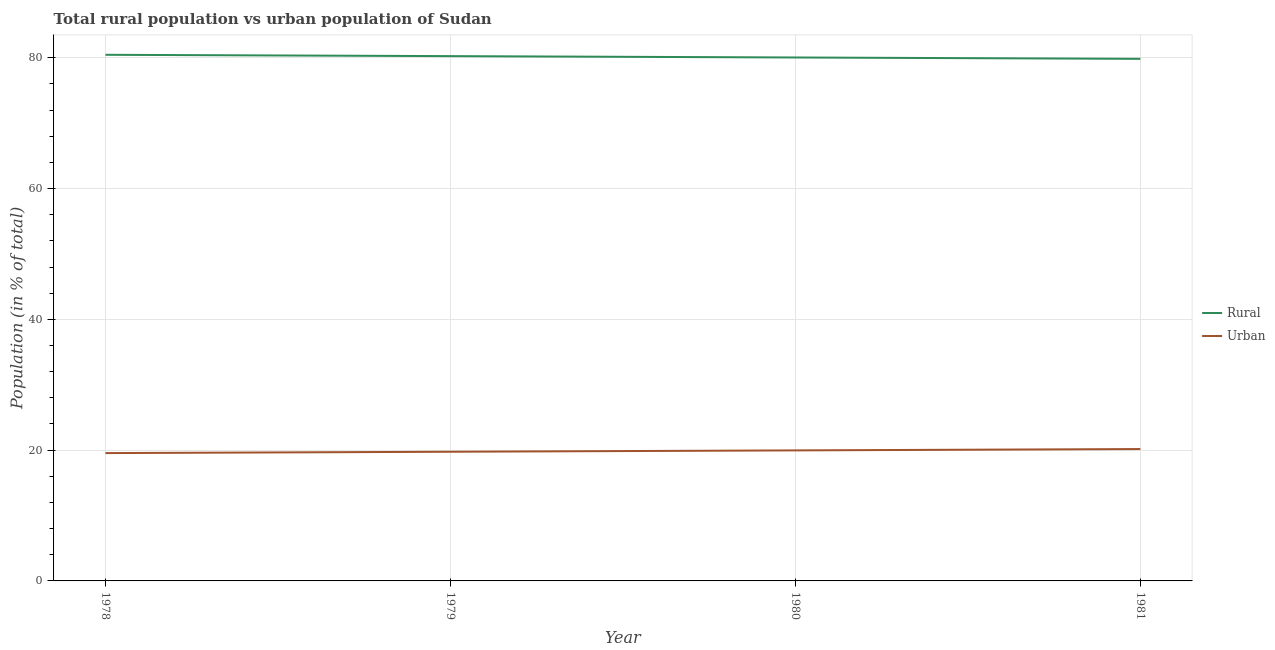Does the line corresponding to rural population intersect with the line corresponding to urban population?
Your response must be concise. No. What is the rural population in 1981?
Ensure brevity in your answer.  79.83. Across all years, what is the maximum urban population?
Offer a terse response. 20.17. Across all years, what is the minimum urban population?
Make the answer very short. 19.55. In which year was the urban population minimum?
Ensure brevity in your answer.  1978. What is the total urban population in the graph?
Ensure brevity in your answer.  79.42. What is the difference between the urban population in 1980 and that in 1981?
Offer a terse response. -0.21. What is the difference between the rural population in 1980 and the urban population in 1978?
Your response must be concise. 60.49. What is the average urban population per year?
Make the answer very short. 19.86. In the year 1981, what is the difference between the rural population and urban population?
Give a very brief answer. 59.67. In how many years, is the urban population greater than 68 %?
Keep it short and to the point. 0. What is the ratio of the rural population in 1978 to that in 1979?
Give a very brief answer. 1. Is the difference between the rural population in 1979 and 1981 greater than the difference between the urban population in 1979 and 1981?
Offer a very short reply. Yes. What is the difference between the highest and the second highest urban population?
Offer a very short reply. 0.21. What is the difference between the highest and the lowest urban population?
Your response must be concise. 0.62. In how many years, is the urban population greater than the average urban population taken over all years?
Your answer should be very brief. 2. Is the sum of the urban population in 1980 and 1981 greater than the maximum rural population across all years?
Offer a very short reply. No. Does the urban population monotonically increase over the years?
Keep it short and to the point. Yes. Is the urban population strictly greater than the rural population over the years?
Provide a succinct answer. No. Is the urban population strictly less than the rural population over the years?
Your response must be concise. Yes. How many lines are there?
Your answer should be compact. 2. How many years are there in the graph?
Your answer should be very brief. 4. What is the difference between two consecutive major ticks on the Y-axis?
Your answer should be very brief. 20. Does the graph contain grids?
Make the answer very short. Yes. How many legend labels are there?
Make the answer very short. 2. How are the legend labels stacked?
Provide a succinct answer. Vertical. What is the title of the graph?
Ensure brevity in your answer.  Total rural population vs urban population of Sudan. What is the label or title of the Y-axis?
Your response must be concise. Population (in % of total). What is the Population (in % of total) of Rural in 1978?
Your answer should be compact. 80.45. What is the Population (in % of total) of Urban in 1978?
Provide a succinct answer. 19.55. What is the Population (in % of total) in Rural in 1979?
Offer a terse response. 80.25. What is the Population (in % of total) of Urban in 1979?
Ensure brevity in your answer.  19.75. What is the Population (in % of total) in Rural in 1980?
Make the answer very short. 80.04. What is the Population (in % of total) of Urban in 1980?
Provide a short and direct response. 19.96. What is the Population (in % of total) of Rural in 1981?
Your response must be concise. 79.83. What is the Population (in % of total) in Urban in 1981?
Keep it short and to the point. 20.17. Across all years, what is the maximum Population (in % of total) of Rural?
Your answer should be very brief. 80.45. Across all years, what is the maximum Population (in % of total) in Urban?
Provide a succinct answer. 20.17. Across all years, what is the minimum Population (in % of total) of Rural?
Provide a short and direct response. 79.83. Across all years, what is the minimum Population (in % of total) in Urban?
Your answer should be compact. 19.55. What is the total Population (in % of total) in Rural in the graph?
Ensure brevity in your answer.  320.58. What is the total Population (in % of total) in Urban in the graph?
Your answer should be compact. 79.42. What is the difference between the Population (in % of total) of Rural in 1978 and that in 1979?
Ensure brevity in your answer.  0.2. What is the difference between the Population (in % of total) of Urban in 1978 and that in 1979?
Offer a very short reply. -0.2. What is the difference between the Population (in % of total) in Rural in 1978 and that in 1980?
Offer a terse response. 0.41. What is the difference between the Population (in % of total) of Urban in 1978 and that in 1980?
Make the answer very short. -0.41. What is the difference between the Population (in % of total) in Rural in 1978 and that in 1981?
Provide a short and direct response. 0.62. What is the difference between the Population (in % of total) of Urban in 1978 and that in 1981?
Provide a short and direct response. -0.62. What is the difference between the Population (in % of total) in Rural in 1979 and that in 1980?
Make the answer very short. 0.21. What is the difference between the Population (in % of total) of Urban in 1979 and that in 1980?
Provide a succinct answer. -0.21. What is the difference between the Population (in % of total) in Rural in 1979 and that in 1981?
Keep it short and to the point. 0.41. What is the difference between the Population (in % of total) of Urban in 1979 and that in 1981?
Make the answer very short. -0.41. What is the difference between the Population (in % of total) of Rural in 1980 and that in 1981?
Your response must be concise. 0.21. What is the difference between the Population (in % of total) in Urban in 1980 and that in 1981?
Offer a very short reply. -0.21. What is the difference between the Population (in % of total) of Rural in 1978 and the Population (in % of total) of Urban in 1979?
Your response must be concise. 60.7. What is the difference between the Population (in % of total) in Rural in 1978 and the Population (in % of total) in Urban in 1980?
Provide a succinct answer. 60.49. What is the difference between the Population (in % of total) of Rural in 1978 and the Population (in % of total) of Urban in 1981?
Your answer should be compact. 60.29. What is the difference between the Population (in % of total) in Rural in 1979 and the Population (in % of total) in Urban in 1980?
Ensure brevity in your answer.  60.29. What is the difference between the Population (in % of total) of Rural in 1979 and the Population (in % of total) of Urban in 1981?
Your answer should be very brief. 60.08. What is the difference between the Population (in % of total) in Rural in 1980 and the Population (in % of total) in Urban in 1981?
Your answer should be compact. 59.88. What is the average Population (in % of total) of Rural per year?
Keep it short and to the point. 80.14. What is the average Population (in % of total) in Urban per year?
Your answer should be very brief. 19.86. In the year 1978, what is the difference between the Population (in % of total) of Rural and Population (in % of total) of Urban?
Ensure brevity in your answer.  60.91. In the year 1979, what is the difference between the Population (in % of total) in Rural and Population (in % of total) in Urban?
Make the answer very short. 60.5. In the year 1980, what is the difference between the Population (in % of total) of Rural and Population (in % of total) of Urban?
Offer a terse response. 60.08. In the year 1981, what is the difference between the Population (in % of total) of Rural and Population (in % of total) of Urban?
Ensure brevity in your answer.  59.67. What is the ratio of the Population (in % of total) of Urban in 1978 to that in 1980?
Ensure brevity in your answer.  0.98. What is the ratio of the Population (in % of total) in Urban in 1978 to that in 1981?
Offer a terse response. 0.97. What is the ratio of the Population (in % of total) in Rural in 1979 to that in 1980?
Give a very brief answer. 1. What is the ratio of the Population (in % of total) in Rural in 1979 to that in 1981?
Give a very brief answer. 1.01. What is the ratio of the Population (in % of total) of Urban in 1979 to that in 1981?
Give a very brief answer. 0.98. What is the ratio of the Population (in % of total) in Urban in 1980 to that in 1981?
Keep it short and to the point. 0.99. What is the difference between the highest and the second highest Population (in % of total) of Rural?
Ensure brevity in your answer.  0.2. What is the difference between the highest and the second highest Population (in % of total) of Urban?
Ensure brevity in your answer.  0.21. What is the difference between the highest and the lowest Population (in % of total) in Rural?
Provide a short and direct response. 0.62. What is the difference between the highest and the lowest Population (in % of total) of Urban?
Provide a short and direct response. 0.62. 